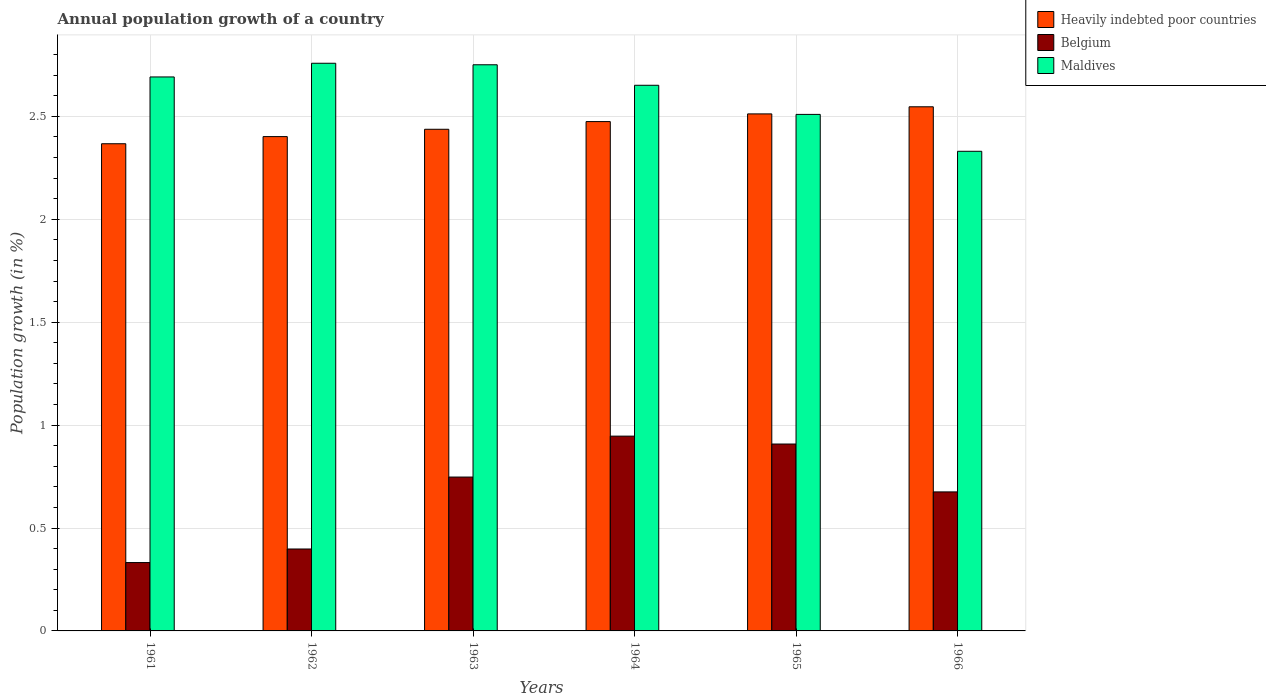How many different coloured bars are there?
Keep it short and to the point. 3. How many bars are there on the 6th tick from the left?
Offer a terse response. 3. How many bars are there on the 6th tick from the right?
Your answer should be very brief. 3. What is the label of the 5th group of bars from the left?
Keep it short and to the point. 1965. In how many cases, is the number of bars for a given year not equal to the number of legend labels?
Your answer should be compact. 0. What is the annual population growth in Maldives in 1965?
Ensure brevity in your answer.  2.51. Across all years, what is the maximum annual population growth in Belgium?
Provide a short and direct response. 0.95. Across all years, what is the minimum annual population growth in Belgium?
Provide a succinct answer. 0.33. In which year was the annual population growth in Heavily indebted poor countries maximum?
Offer a terse response. 1966. What is the total annual population growth in Maldives in the graph?
Offer a terse response. 15.69. What is the difference between the annual population growth in Maldives in 1962 and that in 1966?
Offer a very short reply. 0.43. What is the difference between the annual population growth in Belgium in 1961 and the annual population growth in Maldives in 1964?
Your answer should be compact. -2.32. What is the average annual population growth in Belgium per year?
Offer a terse response. 0.67. In the year 1962, what is the difference between the annual population growth in Maldives and annual population growth in Belgium?
Your answer should be compact. 2.36. In how many years, is the annual population growth in Maldives greater than 0.8 %?
Provide a short and direct response. 6. What is the ratio of the annual population growth in Belgium in 1964 to that in 1965?
Keep it short and to the point. 1.04. Is the difference between the annual population growth in Maldives in 1962 and 1963 greater than the difference between the annual population growth in Belgium in 1962 and 1963?
Ensure brevity in your answer.  Yes. What is the difference between the highest and the second highest annual population growth in Belgium?
Provide a succinct answer. 0.04. What is the difference between the highest and the lowest annual population growth in Belgium?
Provide a succinct answer. 0.61. Is the sum of the annual population growth in Belgium in 1963 and 1964 greater than the maximum annual population growth in Maldives across all years?
Provide a short and direct response. No. What does the 1st bar from the left in 1962 represents?
Your answer should be compact. Heavily indebted poor countries. What does the 3rd bar from the right in 1964 represents?
Your answer should be compact. Heavily indebted poor countries. How many bars are there?
Your answer should be very brief. 18. Are all the bars in the graph horizontal?
Ensure brevity in your answer.  No. What is the difference between two consecutive major ticks on the Y-axis?
Offer a terse response. 0.5. Are the values on the major ticks of Y-axis written in scientific E-notation?
Make the answer very short. No. Does the graph contain grids?
Keep it short and to the point. Yes. Where does the legend appear in the graph?
Your answer should be very brief. Top right. How many legend labels are there?
Provide a short and direct response. 3. What is the title of the graph?
Your answer should be compact. Annual population growth of a country. Does "Djibouti" appear as one of the legend labels in the graph?
Give a very brief answer. No. What is the label or title of the X-axis?
Make the answer very short. Years. What is the label or title of the Y-axis?
Your answer should be very brief. Population growth (in %). What is the Population growth (in %) of Heavily indebted poor countries in 1961?
Your answer should be very brief. 2.37. What is the Population growth (in %) of Belgium in 1961?
Your answer should be compact. 0.33. What is the Population growth (in %) of Maldives in 1961?
Provide a succinct answer. 2.69. What is the Population growth (in %) of Heavily indebted poor countries in 1962?
Your response must be concise. 2.4. What is the Population growth (in %) in Belgium in 1962?
Make the answer very short. 0.4. What is the Population growth (in %) in Maldives in 1962?
Keep it short and to the point. 2.76. What is the Population growth (in %) of Heavily indebted poor countries in 1963?
Provide a succinct answer. 2.44. What is the Population growth (in %) of Belgium in 1963?
Ensure brevity in your answer.  0.75. What is the Population growth (in %) of Maldives in 1963?
Your answer should be very brief. 2.75. What is the Population growth (in %) of Heavily indebted poor countries in 1964?
Offer a very short reply. 2.47. What is the Population growth (in %) in Belgium in 1964?
Give a very brief answer. 0.95. What is the Population growth (in %) in Maldives in 1964?
Keep it short and to the point. 2.65. What is the Population growth (in %) in Heavily indebted poor countries in 1965?
Make the answer very short. 2.51. What is the Population growth (in %) in Belgium in 1965?
Make the answer very short. 0.91. What is the Population growth (in %) of Maldives in 1965?
Give a very brief answer. 2.51. What is the Population growth (in %) in Heavily indebted poor countries in 1966?
Offer a very short reply. 2.55. What is the Population growth (in %) of Belgium in 1966?
Your answer should be compact. 0.68. What is the Population growth (in %) in Maldives in 1966?
Your answer should be compact. 2.33. Across all years, what is the maximum Population growth (in %) in Heavily indebted poor countries?
Provide a short and direct response. 2.55. Across all years, what is the maximum Population growth (in %) of Belgium?
Provide a short and direct response. 0.95. Across all years, what is the maximum Population growth (in %) in Maldives?
Provide a succinct answer. 2.76. Across all years, what is the minimum Population growth (in %) of Heavily indebted poor countries?
Your answer should be very brief. 2.37. Across all years, what is the minimum Population growth (in %) of Belgium?
Ensure brevity in your answer.  0.33. Across all years, what is the minimum Population growth (in %) in Maldives?
Ensure brevity in your answer.  2.33. What is the total Population growth (in %) in Heavily indebted poor countries in the graph?
Provide a succinct answer. 14.74. What is the total Population growth (in %) in Belgium in the graph?
Give a very brief answer. 4.01. What is the total Population growth (in %) in Maldives in the graph?
Make the answer very short. 15.69. What is the difference between the Population growth (in %) of Heavily indebted poor countries in 1961 and that in 1962?
Ensure brevity in your answer.  -0.03. What is the difference between the Population growth (in %) of Belgium in 1961 and that in 1962?
Keep it short and to the point. -0.07. What is the difference between the Population growth (in %) of Maldives in 1961 and that in 1962?
Give a very brief answer. -0.07. What is the difference between the Population growth (in %) of Heavily indebted poor countries in 1961 and that in 1963?
Give a very brief answer. -0.07. What is the difference between the Population growth (in %) of Belgium in 1961 and that in 1963?
Keep it short and to the point. -0.42. What is the difference between the Population growth (in %) in Maldives in 1961 and that in 1963?
Your response must be concise. -0.06. What is the difference between the Population growth (in %) in Heavily indebted poor countries in 1961 and that in 1964?
Your answer should be compact. -0.11. What is the difference between the Population growth (in %) in Belgium in 1961 and that in 1964?
Ensure brevity in your answer.  -0.61. What is the difference between the Population growth (in %) of Maldives in 1961 and that in 1964?
Your answer should be compact. 0.04. What is the difference between the Population growth (in %) in Heavily indebted poor countries in 1961 and that in 1965?
Offer a terse response. -0.14. What is the difference between the Population growth (in %) in Belgium in 1961 and that in 1965?
Offer a terse response. -0.58. What is the difference between the Population growth (in %) of Maldives in 1961 and that in 1965?
Offer a very short reply. 0.18. What is the difference between the Population growth (in %) of Heavily indebted poor countries in 1961 and that in 1966?
Keep it short and to the point. -0.18. What is the difference between the Population growth (in %) of Belgium in 1961 and that in 1966?
Your answer should be very brief. -0.34. What is the difference between the Population growth (in %) of Maldives in 1961 and that in 1966?
Your response must be concise. 0.36. What is the difference between the Population growth (in %) of Heavily indebted poor countries in 1962 and that in 1963?
Offer a terse response. -0.04. What is the difference between the Population growth (in %) of Belgium in 1962 and that in 1963?
Provide a short and direct response. -0.35. What is the difference between the Population growth (in %) of Maldives in 1962 and that in 1963?
Make the answer very short. 0.01. What is the difference between the Population growth (in %) of Heavily indebted poor countries in 1962 and that in 1964?
Offer a terse response. -0.07. What is the difference between the Population growth (in %) in Belgium in 1962 and that in 1964?
Ensure brevity in your answer.  -0.55. What is the difference between the Population growth (in %) of Maldives in 1962 and that in 1964?
Ensure brevity in your answer.  0.11. What is the difference between the Population growth (in %) in Heavily indebted poor countries in 1962 and that in 1965?
Your response must be concise. -0.11. What is the difference between the Population growth (in %) in Belgium in 1962 and that in 1965?
Provide a succinct answer. -0.51. What is the difference between the Population growth (in %) of Maldives in 1962 and that in 1965?
Your answer should be very brief. 0.25. What is the difference between the Population growth (in %) in Heavily indebted poor countries in 1962 and that in 1966?
Ensure brevity in your answer.  -0.14. What is the difference between the Population growth (in %) of Belgium in 1962 and that in 1966?
Keep it short and to the point. -0.28. What is the difference between the Population growth (in %) of Maldives in 1962 and that in 1966?
Make the answer very short. 0.43. What is the difference between the Population growth (in %) of Heavily indebted poor countries in 1963 and that in 1964?
Provide a succinct answer. -0.04. What is the difference between the Population growth (in %) of Belgium in 1963 and that in 1964?
Offer a very short reply. -0.2. What is the difference between the Population growth (in %) of Maldives in 1963 and that in 1964?
Offer a very short reply. 0.1. What is the difference between the Population growth (in %) of Heavily indebted poor countries in 1963 and that in 1965?
Give a very brief answer. -0.07. What is the difference between the Population growth (in %) in Belgium in 1963 and that in 1965?
Offer a very short reply. -0.16. What is the difference between the Population growth (in %) of Maldives in 1963 and that in 1965?
Provide a succinct answer. 0.24. What is the difference between the Population growth (in %) in Heavily indebted poor countries in 1963 and that in 1966?
Give a very brief answer. -0.11. What is the difference between the Population growth (in %) of Belgium in 1963 and that in 1966?
Give a very brief answer. 0.07. What is the difference between the Population growth (in %) of Maldives in 1963 and that in 1966?
Ensure brevity in your answer.  0.42. What is the difference between the Population growth (in %) of Heavily indebted poor countries in 1964 and that in 1965?
Provide a succinct answer. -0.04. What is the difference between the Population growth (in %) in Belgium in 1964 and that in 1965?
Make the answer very short. 0.04. What is the difference between the Population growth (in %) of Maldives in 1964 and that in 1965?
Your response must be concise. 0.14. What is the difference between the Population growth (in %) in Heavily indebted poor countries in 1964 and that in 1966?
Ensure brevity in your answer.  -0.07. What is the difference between the Population growth (in %) of Belgium in 1964 and that in 1966?
Your answer should be very brief. 0.27. What is the difference between the Population growth (in %) in Maldives in 1964 and that in 1966?
Ensure brevity in your answer.  0.32. What is the difference between the Population growth (in %) of Heavily indebted poor countries in 1965 and that in 1966?
Your response must be concise. -0.03. What is the difference between the Population growth (in %) of Belgium in 1965 and that in 1966?
Your response must be concise. 0.23. What is the difference between the Population growth (in %) of Maldives in 1965 and that in 1966?
Your response must be concise. 0.18. What is the difference between the Population growth (in %) in Heavily indebted poor countries in 1961 and the Population growth (in %) in Belgium in 1962?
Give a very brief answer. 1.97. What is the difference between the Population growth (in %) in Heavily indebted poor countries in 1961 and the Population growth (in %) in Maldives in 1962?
Provide a short and direct response. -0.39. What is the difference between the Population growth (in %) of Belgium in 1961 and the Population growth (in %) of Maldives in 1962?
Give a very brief answer. -2.43. What is the difference between the Population growth (in %) of Heavily indebted poor countries in 1961 and the Population growth (in %) of Belgium in 1963?
Provide a succinct answer. 1.62. What is the difference between the Population growth (in %) in Heavily indebted poor countries in 1961 and the Population growth (in %) in Maldives in 1963?
Make the answer very short. -0.38. What is the difference between the Population growth (in %) of Belgium in 1961 and the Population growth (in %) of Maldives in 1963?
Keep it short and to the point. -2.42. What is the difference between the Population growth (in %) of Heavily indebted poor countries in 1961 and the Population growth (in %) of Belgium in 1964?
Give a very brief answer. 1.42. What is the difference between the Population growth (in %) of Heavily indebted poor countries in 1961 and the Population growth (in %) of Maldives in 1964?
Your answer should be very brief. -0.28. What is the difference between the Population growth (in %) of Belgium in 1961 and the Population growth (in %) of Maldives in 1964?
Offer a terse response. -2.32. What is the difference between the Population growth (in %) in Heavily indebted poor countries in 1961 and the Population growth (in %) in Belgium in 1965?
Provide a succinct answer. 1.46. What is the difference between the Population growth (in %) in Heavily indebted poor countries in 1961 and the Population growth (in %) in Maldives in 1965?
Ensure brevity in your answer.  -0.14. What is the difference between the Population growth (in %) of Belgium in 1961 and the Population growth (in %) of Maldives in 1965?
Give a very brief answer. -2.18. What is the difference between the Population growth (in %) in Heavily indebted poor countries in 1961 and the Population growth (in %) in Belgium in 1966?
Your response must be concise. 1.69. What is the difference between the Population growth (in %) in Heavily indebted poor countries in 1961 and the Population growth (in %) in Maldives in 1966?
Give a very brief answer. 0.04. What is the difference between the Population growth (in %) in Belgium in 1961 and the Population growth (in %) in Maldives in 1966?
Offer a terse response. -2. What is the difference between the Population growth (in %) of Heavily indebted poor countries in 1962 and the Population growth (in %) of Belgium in 1963?
Your response must be concise. 1.65. What is the difference between the Population growth (in %) in Heavily indebted poor countries in 1962 and the Population growth (in %) in Maldives in 1963?
Your answer should be very brief. -0.35. What is the difference between the Population growth (in %) in Belgium in 1962 and the Population growth (in %) in Maldives in 1963?
Provide a succinct answer. -2.35. What is the difference between the Population growth (in %) in Heavily indebted poor countries in 1962 and the Population growth (in %) in Belgium in 1964?
Your answer should be compact. 1.46. What is the difference between the Population growth (in %) in Heavily indebted poor countries in 1962 and the Population growth (in %) in Maldives in 1964?
Make the answer very short. -0.25. What is the difference between the Population growth (in %) in Belgium in 1962 and the Population growth (in %) in Maldives in 1964?
Offer a very short reply. -2.25. What is the difference between the Population growth (in %) of Heavily indebted poor countries in 1962 and the Population growth (in %) of Belgium in 1965?
Give a very brief answer. 1.49. What is the difference between the Population growth (in %) in Heavily indebted poor countries in 1962 and the Population growth (in %) in Maldives in 1965?
Provide a succinct answer. -0.11. What is the difference between the Population growth (in %) in Belgium in 1962 and the Population growth (in %) in Maldives in 1965?
Give a very brief answer. -2.11. What is the difference between the Population growth (in %) in Heavily indebted poor countries in 1962 and the Population growth (in %) in Belgium in 1966?
Make the answer very short. 1.73. What is the difference between the Population growth (in %) of Heavily indebted poor countries in 1962 and the Population growth (in %) of Maldives in 1966?
Your answer should be very brief. 0.07. What is the difference between the Population growth (in %) in Belgium in 1962 and the Population growth (in %) in Maldives in 1966?
Ensure brevity in your answer.  -1.93. What is the difference between the Population growth (in %) of Heavily indebted poor countries in 1963 and the Population growth (in %) of Belgium in 1964?
Your answer should be compact. 1.49. What is the difference between the Population growth (in %) in Heavily indebted poor countries in 1963 and the Population growth (in %) in Maldives in 1964?
Offer a very short reply. -0.21. What is the difference between the Population growth (in %) in Belgium in 1963 and the Population growth (in %) in Maldives in 1964?
Give a very brief answer. -1.9. What is the difference between the Population growth (in %) in Heavily indebted poor countries in 1963 and the Population growth (in %) in Belgium in 1965?
Your response must be concise. 1.53. What is the difference between the Population growth (in %) in Heavily indebted poor countries in 1963 and the Population growth (in %) in Maldives in 1965?
Ensure brevity in your answer.  -0.07. What is the difference between the Population growth (in %) in Belgium in 1963 and the Population growth (in %) in Maldives in 1965?
Your answer should be compact. -1.76. What is the difference between the Population growth (in %) in Heavily indebted poor countries in 1963 and the Population growth (in %) in Belgium in 1966?
Keep it short and to the point. 1.76. What is the difference between the Population growth (in %) of Heavily indebted poor countries in 1963 and the Population growth (in %) of Maldives in 1966?
Provide a succinct answer. 0.11. What is the difference between the Population growth (in %) of Belgium in 1963 and the Population growth (in %) of Maldives in 1966?
Your answer should be very brief. -1.58. What is the difference between the Population growth (in %) of Heavily indebted poor countries in 1964 and the Population growth (in %) of Belgium in 1965?
Offer a terse response. 1.57. What is the difference between the Population growth (in %) of Heavily indebted poor countries in 1964 and the Population growth (in %) of Maldives in 1965?
Provide a short and direct response. -0.04. What is the difference between the Population growth (in %) of Belgium in 1964 and the Population growth (in %) of Maldives in 1965?
Ensure brevity in your answer.  -1.56. What is the difference between the Population growth (in %) of Heavily indebted poor countries in 1964 and the Population growth (in %) of Belgium in 1966?
Your answer should be very brief. 1.8. What is the difference between the Population growth (in %) of Heavily indebted poor countries in 1964 and the Population growth (in %) of Maldives in 1966?
Make the answer very short. 0.14. What is the difference between the Population growth (in %) of Belgium in 1964 and the Population growth (in %) of Maldives in 1966?
Offer a terse response. -1.38. What is the difference between the Population growth (in %) in Heavily indebted poor countries in 1965 and the Population growth (in %) in Belgium in 1966?
Your response must be concise. 1.84. What is the difference between the Population growth (in %) of Heavily indebted poor countries in 1965 and the Population growth (in %) of Maldives in 1966?
Offer a terse response. 0.18. What is the difference between the Population growth (in %) of Belgium in 1965 and the Population growth (in %) of Maldives in 1966?
Ensure brevity in your answer.  -1.42. What is the average Population growth (in %) in Heavily indebted poor countries per year?
Ensure brevity in your answer.  2.46. What is the average Population growth (in %) of Belgium per year?
Give a very brief answer. 0.67. What is the average Population growth (in %) of Maldives per year?
Ensure brevity in your answer.  2.62. In the year 1961, what is the difference between the Population growth (in %) of Heavily indebted poor countries and Population growth (in %) of Belgium?
Provide a short and direct response. 2.03. In the year 1961, what is the difference between the Population growth (in %) of Heavily indebted poor countries and Population growth (in %) of Maldives?
Your answer should be very brief. -0.32. In the year 1961, what is the difference between the Population growth (in %) of Belgium and Population growth (in %) of Maldives?
Ensure brevity in your answer.  -2.36. In the year 1962, what is the difference between the Population growth (in %) in Heavily indebted poor countries and Population growth (in %) in Belgium?
Offer a very short reply. 2. In the year 1962, what is the difference between the Population growth (in %) of Heavily indebted poor countries and Population growth (in %) of Maldives?
Provide a short and direct response. -0.36. In the year 1962, what is the difference between the Population growth (in %) of Belgium and Population growth (in %) of Maldives?
Offer a very short reply. -2.36. In the year 1963, what is the difference between the Population growth (in %) in Heavily indebted poor countries and Population growth (in %) in Belgium?
Offer a terse response. 1.69. In the year 1963, what is the difference between the Population growth (in %) of Heavily indebted poor countries and Population growth (in %) of Maldives?
Ensure brevity in your answer.  -0.31. In the year 1963, what is the difference between the Population growth (in %) in Belgium and Population growth (in %) in Maldives?
Your answer should be compact. -2. In the year 1964, what is the difference between the Population growth (in %) in Heavily indebted poor countries and Population growth (in %) in Belgium?
Provide a short and direct response. 1.53. In the year 1964, what is the difference between the Population growth (in %) of Heavily indebted poor countries and Population growth (in %) of Maldives?
Your answer should be very brief. -0.18. In the year 1964, what is the difference between the Population growth (in %) in Belgium and Population growth (in %) in Maldives?
Offer a very short reply. -1.7. In the year 1965, what is the difference between the Population growth (in %) of Heavily indebted poor countries and Population growth (in %) of Belgium?
Give a very brief answer. 1.6. In the year 1965, what is the difference between the Population growth (in %) in Heavily indebted poor countries and Population growth (in %) in Maldives?
Provide a short and direct response. 0. In the year 1965, what is the difference between the Population growth (in %) of Belgium and Population growth (in %) of Maldives?
Your response must be concise. -1.6. In the year 1966, what is the difference between the Population growth (in %) in Heavily indebted poor countries and Population growth (in %) in Belgium?
Make the answer very short. 1.87. In the year 1966, what is the difference between the Population growth (in %) in Heavily indebted poor countries and Population growth (in %) in Maldives?
Provide a short and direct response. 0.22. In the year 1966, what is the difference between the Population growth (in %) in Belgium and Population growth (in %) in Maldives?
Offer a very short reply. -1.66. What is the ratio of the Population growth (in %) of Heavily indebted poor countries in 1961 to that in 1962?
Provide a short and direct response. 0.99. What is the ratio of the Population growth (in %) in Belgium in 1961 to that in 1962?
Keep it short and to the point. 0.83. What is the ratio of the Population growth (in %) of Maldives in 1961 to that in 1962?
Give a very brief answer. 0.98. What is the ratio of the Population growth (in %) of Heavily indebted poor countries in 1961 to that in 1963?
Your answer should be compact. 0.97. What is the ratio of the Population growth (in %) of Belgium in 1961 to that in 1963?
Keep it short and to the point. 0.44. What is the ratio of the Population growth (in %) of Maldives in 1961 to that in 1963?
Your response must be concise. 0.98. What is the ratio of the Population growth (in %) in Heavily indebted poor countries in 1961 to that in 1964?
Offer a terse response. 0.96. What is the ratio of the Population growth (in %) in Belgium in 1961 to that in 1964?
Offer a very short reply. 0.35. What is the ratio of the Population growth (in %) of Maldives in 1961 to that in 1964?
Provide a succinct answer. 1.02. What is the ratio of the Population growth (in %) in Heavily indebted poor countries in 1961 to that in 1965?
Provide a short and direct response. 0.94. What is the ratio of the Population growth (in %) in Belgium in 1961 to that in 1965?
Give a very brief answer. 0.37. What is the ratio of the Population growth (in %) of Maldives in 1961 to that in 1965?
Offer a terse response. 1.07. What is the ratio of the Population growth (in %) of Heavily indebted poor countries in 1961 to that in 1966?
Your answer should be compact. 0.93. What is the ratio of the Population growth (in %) in Belgium in 1961 to that in 1966?
Make the answer very short. 0.49. What is the ratio of the Population growth (in %) in Maldives in 1961 to that in 1966?
Your answer should be compact. 1.16. What is the ratio of the Population growth (in %) in Heavily indebted poor countries in 1962 to that in 1963?
Offer a very short reply. 0.99. What is the ratio of the Population growth (in %) in Belgium in 1962 to that in 1963?
Provide a short and direct response. 0.53. What is the ratio of the Population growth (in %) of Heavily indebted poor countries in 1962 to that in 1964?
Provide a short and direct response. 0.97. What is the ratio of the Population growth (in %) in Belgium in 1962 to that in 1964?
Your answer should be compact. 0.42. What is the ratio of the Population growth (in %) of Maldives in 1962 to that in 1964?
Provide a short and direct response. 1.04. What is the ratio of the Population growth (in %) in Heavily indebted poor countries in 1962 to that in 1965?
Offer a terse response. 0.96. What is the ratio of the Population growth (in %) of Belgium in 1962 to that in 1965?
Offer a terse response. 0.44. What is the ratio of the Population growth (in %) of Maldives in 1962 to that in 1965?
Offer a very short reply. 1.1. What is the ratio of the Population growth (in %) of Heavily indebted poor countries in 1962 to that in 1966?
Provide a succinct answer. 0.94. What is the ratio of the Population growth (in %) in Belgium in 1962 to that in 1966?
Provide a succinct answer. 0.59. What is the ratio of the Population growth (in %) of Maldives in 1962 to that in 1966?
Make the answer very short. 1.18. What is the ratio of the Population growth (in %) of Heavily indebted poor countries in 1963 to that in 1964?
Provide a succinct answer. 0.98. What is the ratio of the Population growth (in %) in Belgium in 1963 to that in 1964?
Your answer should be compact. 0.79. What is the ratio of the Population growth (in %) of Maldives in 1963 to that in 1964?
Ensure brevity in your answer.  1.04. What is the ratio of the Population growth (in %) of Heavily indebted poor countries in 1963 to that in 1965?
Offer a very short reply. 0.97. What is the ratio of the Population growth (in %) in Belgium in 1963 to that in 1965?
Provide a short and direct response. 0.82. What is the ratio of the Population growth (in %) of Maldives in 1963 to that in 1965?
Offer a very short reply. 1.1. What is the ratio of the Population growth (in %) in Heavily indebted poor countries in 1963 to that in 1966?
Offer a terse response. 0.96. What is the ratio of the Population growth (in %) in Belgium in 1963 to that in 1966?
Offer a very short reply. 1.11. What is the ratio of the Population growth (in %) of Maldives in 1963 to that in 1966?
Provide a short and direct response. 1.18. What is the ratio of the Population growth (in %) in Heavily indebted poor countries in 1964 to that in 1965?
Your answer should be very brief. 0.99. What is the ratio of the Population growth (in %) of Belgium in 1964 to that in 1965?
Your response must be concise. 1.04. What is the ratio of the Population growth (in %) of Maldives in 1964 to that in 1965?
Keep it short and to the point. 1.06. What is the ratio of the Population growth (in %) of Heavily indebted poor countries in 1964 to that in 1966?
Provide a succinct answer. 0.97. What is the ratio of the Population growth (in %) of Belgium in 1964 to that in 1966?
Your response must be concise. 1.4. What is the ratio of the Population growth (in %) in Maldives in 1964 to that in 1966?
Offer a terse response. 1.14. What is the ratio of the Population growth (in %) in Heavily indebted poor countries in 1965 to that in 1966?
Keep it short and to the point. 0.99. What is the ratio of the Population growth (in %) of Belgium in 1965 to that in 1966?
Give a very brief answer. 1.34. What is the ratio of the Population growth (in %) of Maldives in 1965 to that in 1966?
Provide a succinct answer. 1.08. What is the difference between the highest and the second highest Population growth (in %) of Heavily indebted poor countries?
Offer a very short reply. 0.03. What is the difference between the highest and the second highest Population growth (in %) in Belgium?
Provide a succinct answer. 0.04. What is the difference between the highest and the second highest Population growth (in %) in Maldives?
Your answer should be compact. 0.01. What is the difference between the highest and the lowest Population growth (in %) of Heavily indebted poor countries?
Offer a very short reply. 0.18. What is the difference between the highest and the lowest Population growth (in %) in Belgium?
Make the answer very short. 0.61. What is the difference between the highest and the lowest Population growth (in %) in Maldives?
Make the answer very short. 0.43. 